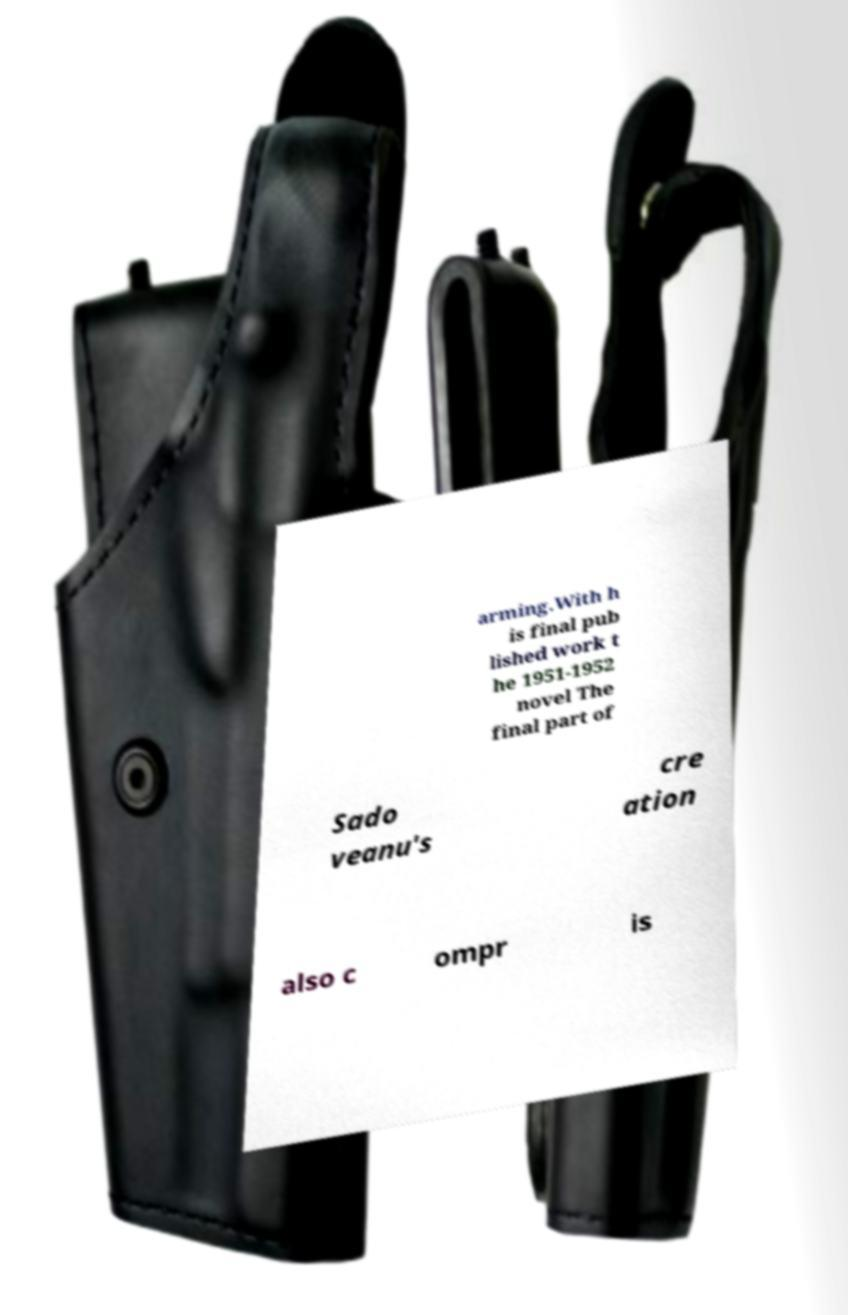Could you assist in decoding the text presented in this image and type it out clearly? arming.With h is final pub lished work t he 1951-1952 novel The final part of Sado veanu's cre ation also c ompr is 